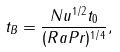Convert formula to latex. <formula><loc_0><loc_0><loc_500><loc_500>t _ { B } = \frac { N u ^ { 1 / 2 } t _ { 0 } } { ( R a P r ) ^ { 1 / 4 } } ,</formula> 